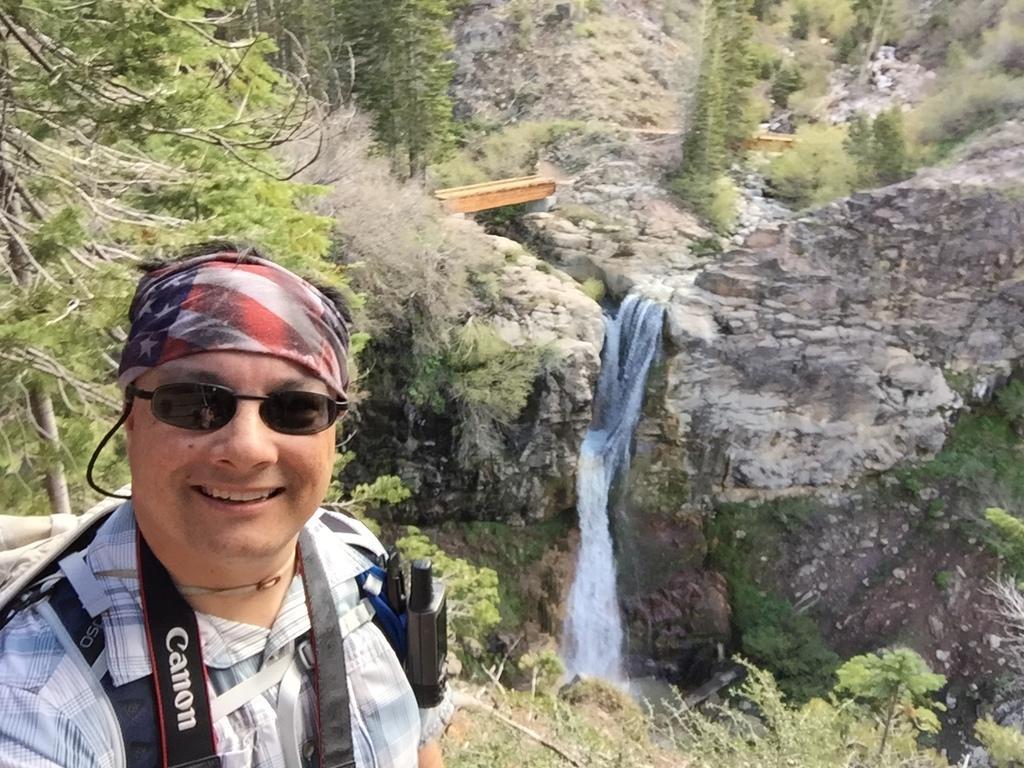Could you give a brief overview of what you see in this image? In this image there is a person standing wearing glasses and a bag, in the background there are trees and a waterfall. 